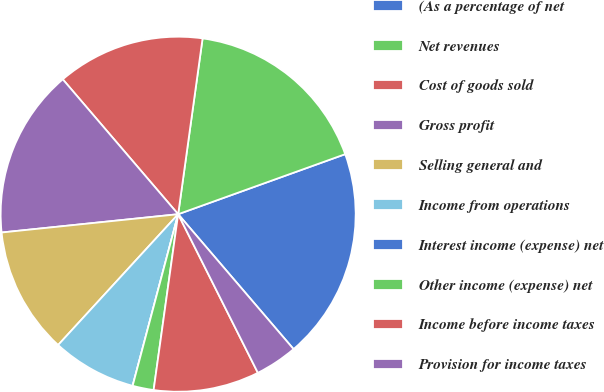<chart> <loc_0><loc_0><loc_500><loc_500><pie_chart><fcel>(As a percentage of net<fcel>Net revenues<fcel>Cost of goods sold<fcel>Gross profit<fcel>Selling general and<fcel>Income from operations<fcel>Interest income (expense) net<fcel>Other income (expense) net<fcel>Income before income taxes<fcel>Provision for income taxes<nl><fcel>19.23%<fcel>17.31%<fcel>13.46%<fcel>15.38%<fcel>11.54%<fcel>7.69%<fcel>0.0%<fcel>1.92%<fcel>9.62%<fcel>3.85%<nl></chart> 